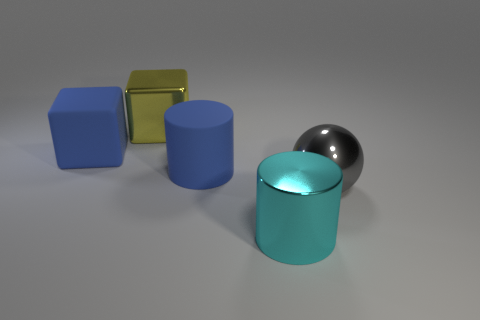Add 3 shiny cylinders. How many objects exist? 8 Add 5 big matte things. How many big matte things are left? 7 Add 3 big yellow cubes. How many big yellow cubes exist? 4 Subtract all yellow cubes. How many cubes are left? 1 Subtract 0 brown blocks. How many objects are left? 5 Subtract all cylinders. How many objects are left? 3 Subtract 1 spheres. How many spheres are left? 0 Subtract all cyan cubes. Subtract all purple cylinders. How many cubes are left? 2 Subtract all cyan cylinders. How many yellow blocks are left? 1 Subtract all blue rubber cylinders. Subtract all big metal objects. How many objects are left? 1 